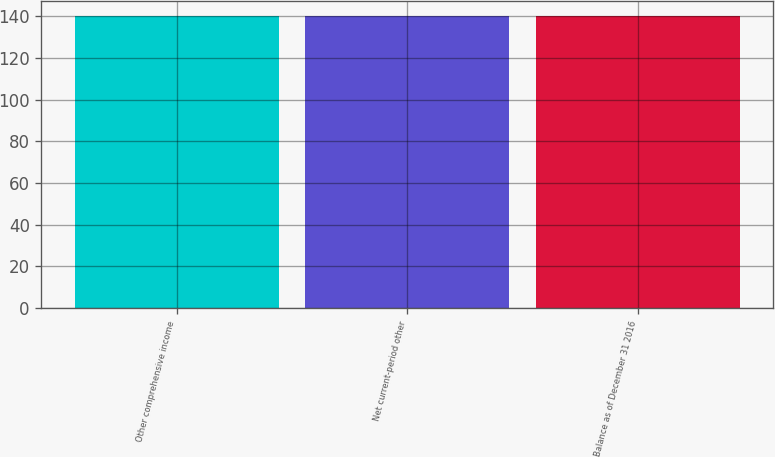Convert chart to OTSL. <chart><loc_0><loc_0><loc_500><loc_500><bar_chart><fcel>Other comprehensive income<fcel>Net current-period other<fcel>Balance as of December 31 2016<nl><fcel>140<fcel>140.1<fcel>140.2<nl></chart> 